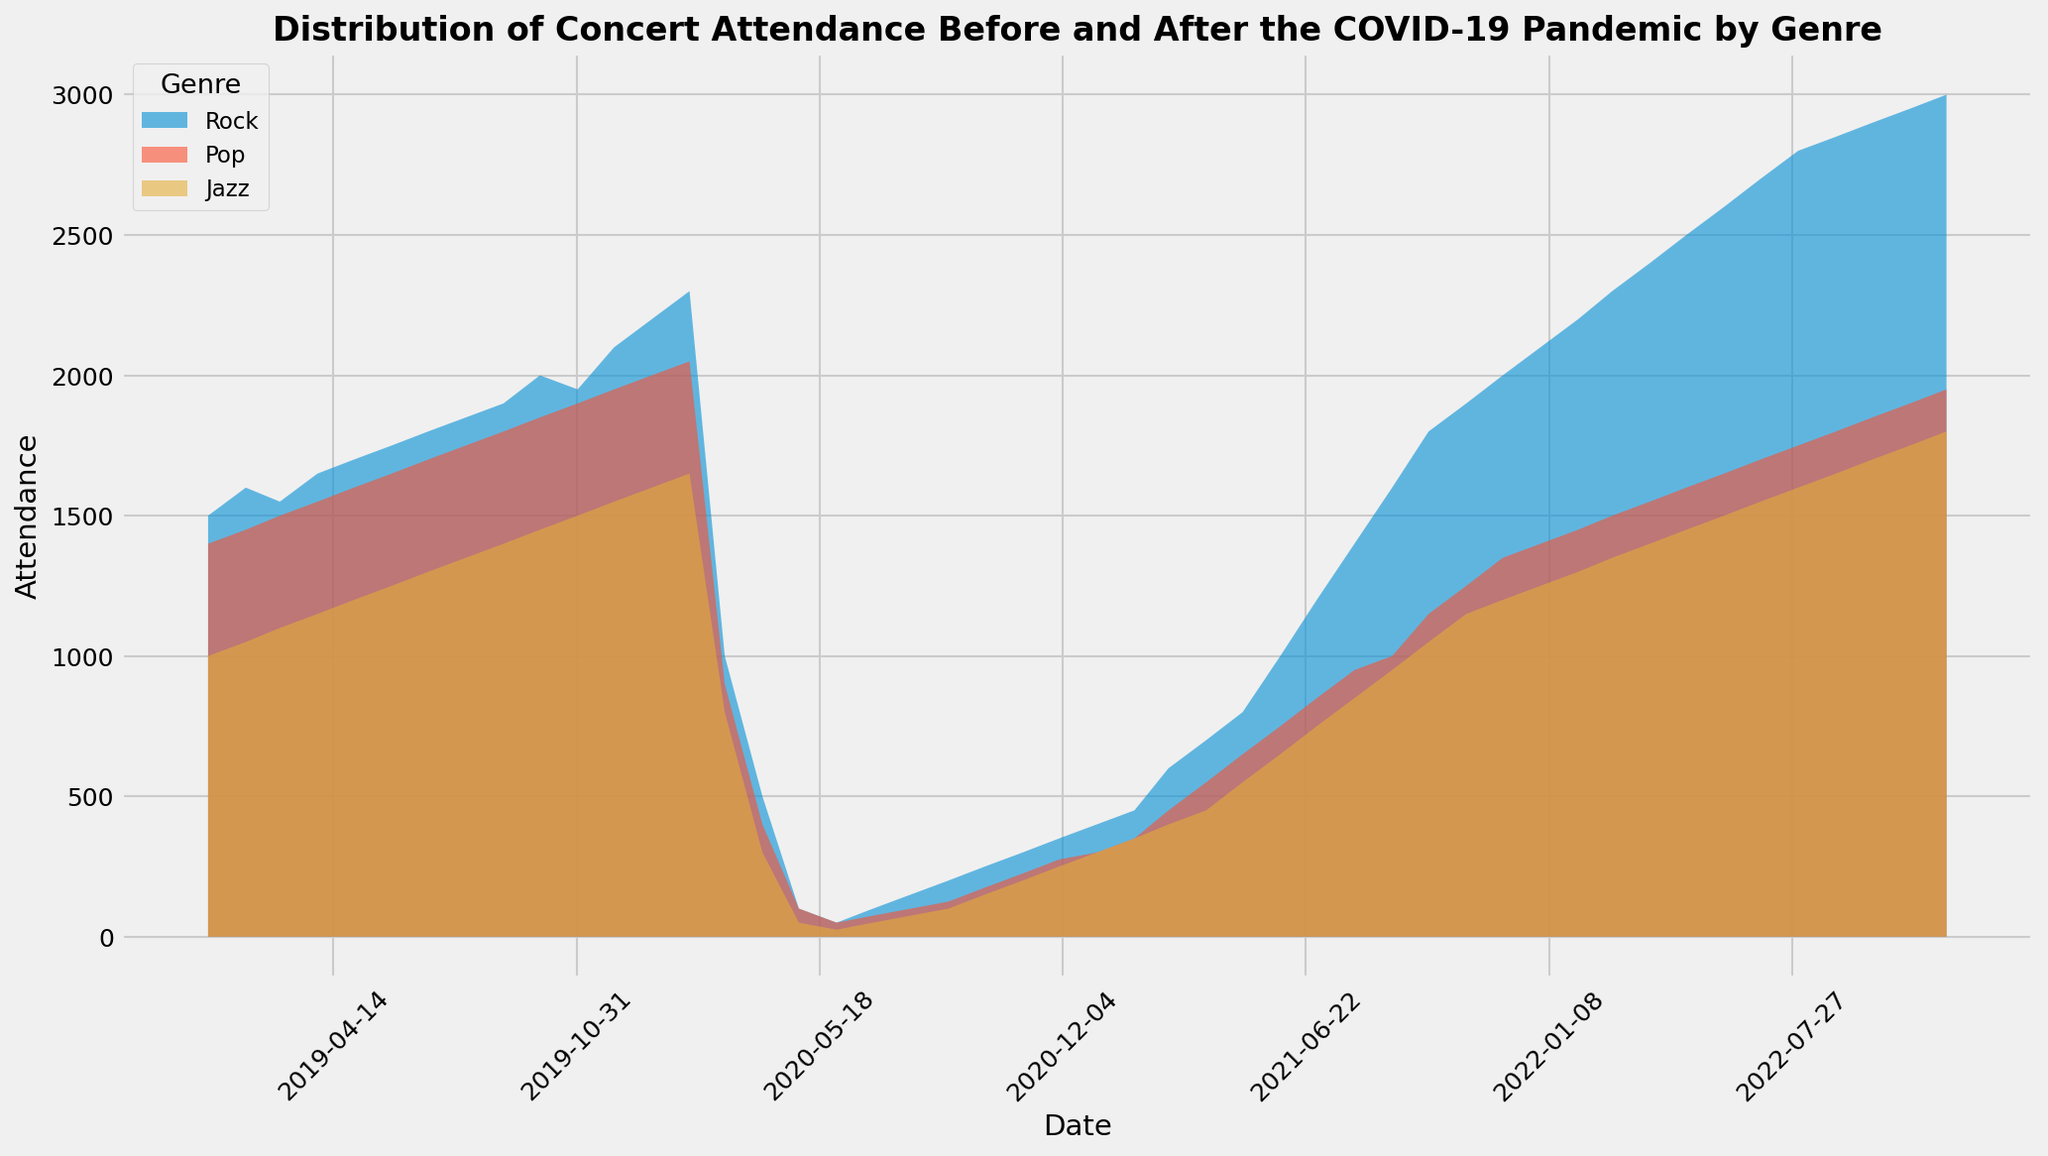What visual trend can be observed in rock concert attendance from January 2019 to December 2020? Review the area chart for the Rock genre. The trend shows a general increase in attendance from January 2019 until February 2020, followed by a significant drop starting in March 2020 due to the COVID-19 pandemic.
Answer: Increasing until February 2020, then a significant drop How did jazz concert attendance change from February 2020 to June 2020? Look at the Jazz section in the area chart. Attendance drops sharply from 1650 in February 2020 to 25 in June 2020.
Answer: It plummeted from 1650 to 25 Which genre had the slowest recovery in attendance after the initial COVID-19 dip? Compare the areas under the chart after the dip in March 2020 for each genre. The Pop genre shows the slowest recovery.
Answer: Pop What is the highest concert attendance for any genre after December 2020? Check the highest points for each genre after December 2020. The highest attendance is for Rock at 3000 in December 2022.
Answer: 3000 Was pop concert attendance in January 2021 higher or lower than jazz concert attendance in the same month? Compare the attendance numbers for Pop and Jazz in January 2021. Pop has 300, and Jazz has 300.
Answer: Equal (300) By how much did rock concert attendance decrease from February 2020 to March 2020? Subtract the attendance in March 2020 from February 2020 for Rock. 2300 - 1000 = 1300
Answer: 1300 Between Rock and Jazz, which genre shows the earliest signs of recovery post drop in 2020? Look for initial increases in attendance after the dip in both genres. Jazz starts to increase slightly in July 2020, whereas Rock starts in August 2020.
Answer: Jazz How much did pop concert attendance increase from October 2021 to December 2021? Subtract the attendance in October 2021 from December 2021 for Pop. 1350 - 1150 = 200
Answer: 200 At what point did rock concert attendance surpass 2000 again after the COVID-19 dip? Find the date where Rock attendance exceeds 2000 after the dip in 2020. This happens in December 2021.
Answer: December 2021 What visual difference stands out between the rock and pop attendance trends before and after the pandemic? Rock shows a more pronounced increase before the pandemic and a sharper drop with a faster recovery after, while Pop has a steadier trend before and much slower recovery after.
Answer: Rock has a sharper drop and faster recovery 